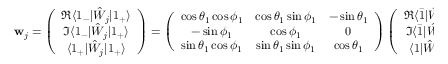<formula> <loc_0><loc_0><loc_500><loc_500>w _ { j } = \left ( \begin{array} { c } { \Re \langle 1 _ { - } | \hat { W } _ { j } | 1 _ { + } \rangle } \\ { \Im \langle 1 _ { - } | \hat { W } _ { j } | 1 _ { + } \rangle } \\ { \langle 1 _ { + } | \hat { W } _ { j } | 1 _ { + } \rangle } \end{array} \right ) = \left ( \begin{array} { c c c } { \cos \theta _ { 1 } \cos \phi _ { 1 } } & { \cos \theta _ { 1 } \sin \phi _ { 1 } } & { - \sin \theta _ { 1 } } \\ { - \sin \phi _ { 1 } } & { \cos \phi _ { 1 } } & { 0 } \\ { \sin \theta _ { 1 } \cos \phi _ { 1 } } & { \sin \theta _ { 1 } \sin \phi _ { 1 } } & { \cos \theta _ { 1 } } \end{array} \right ) \left ( \begin{array} { c } { \Re \langle \bar { 1 } | \hat { W } _ { j } | 1 \rangle } \\ { \Im \langle \bar { 1 } | \hat { W } _ { j } | 1 \rangle } \\ { \langle 1 | \hat { W } _ { j } | 1 \rangle } \end{array} \right ) = R ( \theta _ { 1 } , \phi _ { 1 } ) \cdot \tilde { w } _ { j } .</formula> 